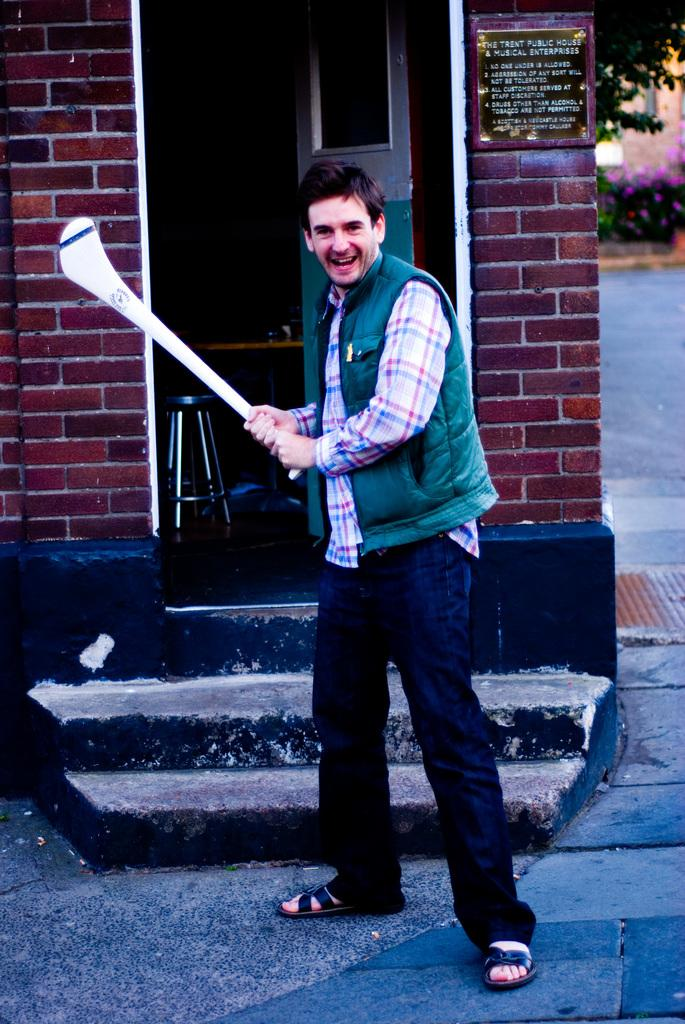What is the person in the image wearing? The person is wearing a green sweater. What is the person holding in their hands? The person is holding a bat in their hands. Where is the person standing in the image? The person is standing on the road. What can be seen in the background of the image? There are stairs, a brick wall, and trees in the background of the image. How many chairs are visible in the image? There are no chairs visible in the image. What type of weight is the person lifting in the image? There is no weight present in the image; the person is holding a bat. 